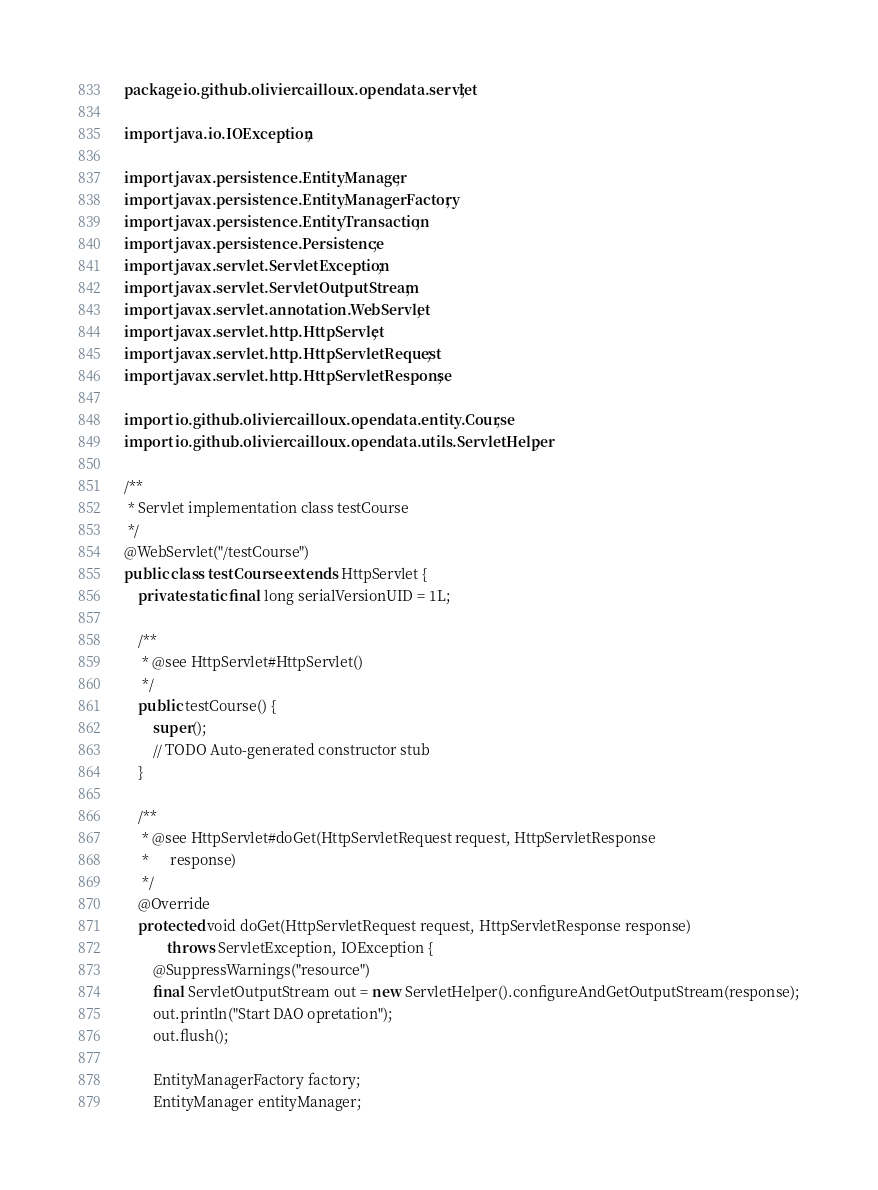<code> <loc_0><loc_0><loc_500><loc_500><_Java_>package io.github.oliviercailloux.opendata.servlet;

import java.io.IOException;

import javax.persistence.EntityManager;
import javax.persistence.EntityManagerFactory;
import javax.persistence.EntityTransaction;
import javax.persistence.Persistence;
import javax.servlet.ServletException;
import javax.servlet.ServletOutputStream;
import javax.servlet.annotation.WebServlet;
import javax.servlet.http.HttpServlet;
import javax.servlet.http.HttpServletRequest;
import javax.servlet.http.HttpServletResponse;

import io.github.oliviercailloux.opendata.entity.Course;
import io.github.oliviercailloux.opendata.utils.ServletHelper;

/**
 * Servlet implementation class testCourse
 */
@WebServlet("/testCourse")
public class testCourse extends HttpServlet {
	private static final long serialVersionUID = 1L;

	/**
	 * @see HttpServlet#HttpServlet()
	 */
	public testCourse() {
		super();
		// TODO Auto-generated constructor stub
	}

	/**
	 * @see HttpServlet#doGet(HttpServletRequest request, HttpServletResponse
	 *      response)
	 */
	@Override
	protected void doGet(HttpServletRequest request, HttpServletResponse response)
			throws ServletException, IOException {
		@SuppressWarnings("resource")
		final ServletOutputStream out = new ServletHelper().configureAndGetOutputStream(response);
		out.println("Start DAO opretation");
		out.flush();

		EntityManagerFactory factory;
		EntityManager entityManager;</code> 